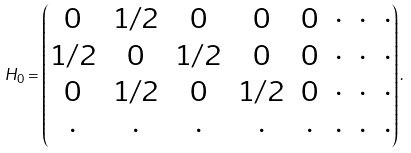Convert formula to latex. <formula><loc_0><loc_0><loc_500><loc_500>H _ { 0 } = \begin{pmatrix} 0 & 1 / 2 & 0 & 0 & 0 & \cdot & \cdot & \cdot \\ 1 / 2 & 0 & 1 / 2 & 0 & 0 & \cdot & \cdot & \cdot \\ 0 & 1 / 2 & 0 & 1 / 2 & 0 & \cdot & \cdot & \cdot \\ \cdot & \cdot & \cdot & \cdot & \cdot & \cdot & \cdot & \cdot \\ \end{pmatrix} .</formula> 